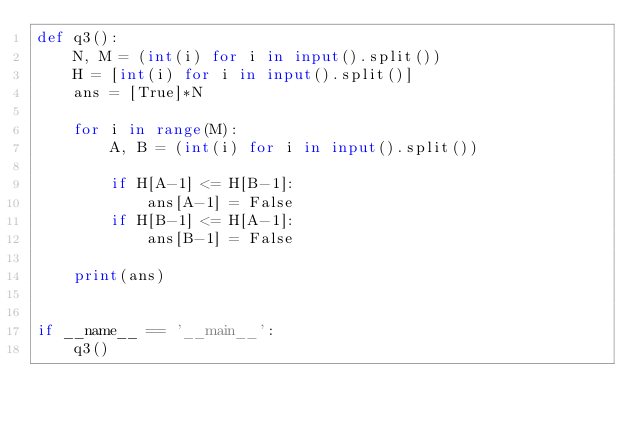Convert code to text. <code><loc_0><loc_0><loc_500><loc_500><_Python_>def q3():
    N, M = (int(i) for i in input().split())
    H = [int(i) for i in input().split()]
    ans = [True]*N

    for i in range(M):
        A, B = (int(i) for i in input().split())

        if H[A-1] <= H[B-1]:
            ans[A-1] = False
        if H[B-1] <= H[A-1]:
            ans[B-1] = False

    print(ans)


if __name__ == '__main__':
    q3()
</code> 